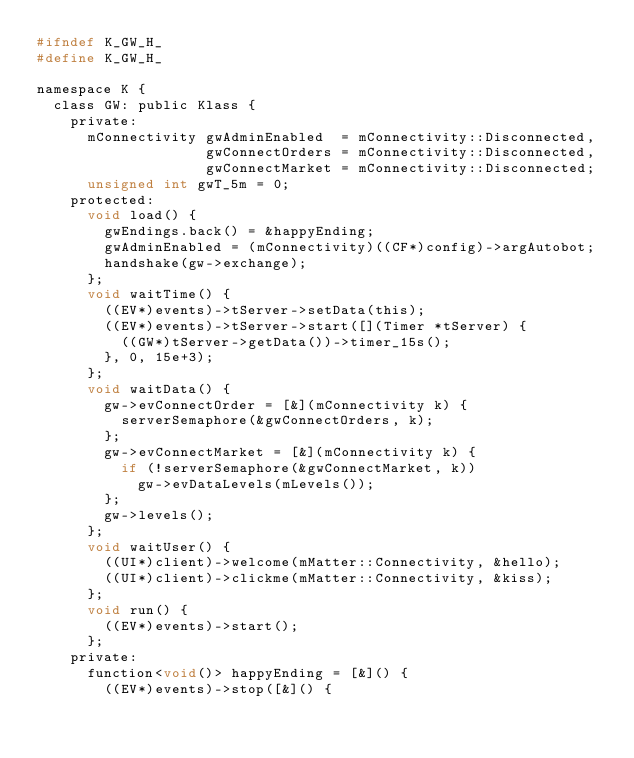Convert code to text. <code><loc_0><loc_0><loc_500><loc_500><_C_>#ifndef K_GW_H_
#define K_GW_H_

namespace K {
  class GW: public Klass {
    private:
      mConnectivity gwAdminEnabled  = mConnectivity::Disconnected,
                    gwConnectOrders = mConnectivity::Disconnected,
                    gwConnectMarket = mConnectivity::Disconnected;
      unsigned int gwT_5m = 0;
    protected:
      void load() {
        gwEndings.back() = &happyEnding;
        gwAdminEnabled = (mConnectivity)((CF*)config)->argAutobot;
        handshake(gw->exchange);
      };
      void waitTime() {
        ((EV*)events)->tServer->setData(this);
        ((EV*)events)->tServer->start([](Timer *tServer) {
          ((GW*)tServer->getData())->timer_15s();
        }, 0, 15e+3);
      };
      void waitData() {
        gw->evConnectOrder = [&](mConnectivity k) {
          serverSemaphore(&gwConnectOrders, k);
        };
        gw->evConnectMarket = [&](mConnectivity k) {
          if (!serverSemaphore(&gwConnectMarket, k))
            gw->evDataLevels(mLevels());
        };
        gw->levels();
      };
      void waitUser() {
        ((UI*)client)->welcome(mMatter::Connectivity, &hello);
        ((UI*)client)->clickme(mMatter::Connectivity, &kiss);
      };
      void run() {
        ((EV*)events)->start();
      };
    private:
      function<void()> happyEnding = [&]() {
        ((EV*)events)->stop([&]() {</code> 